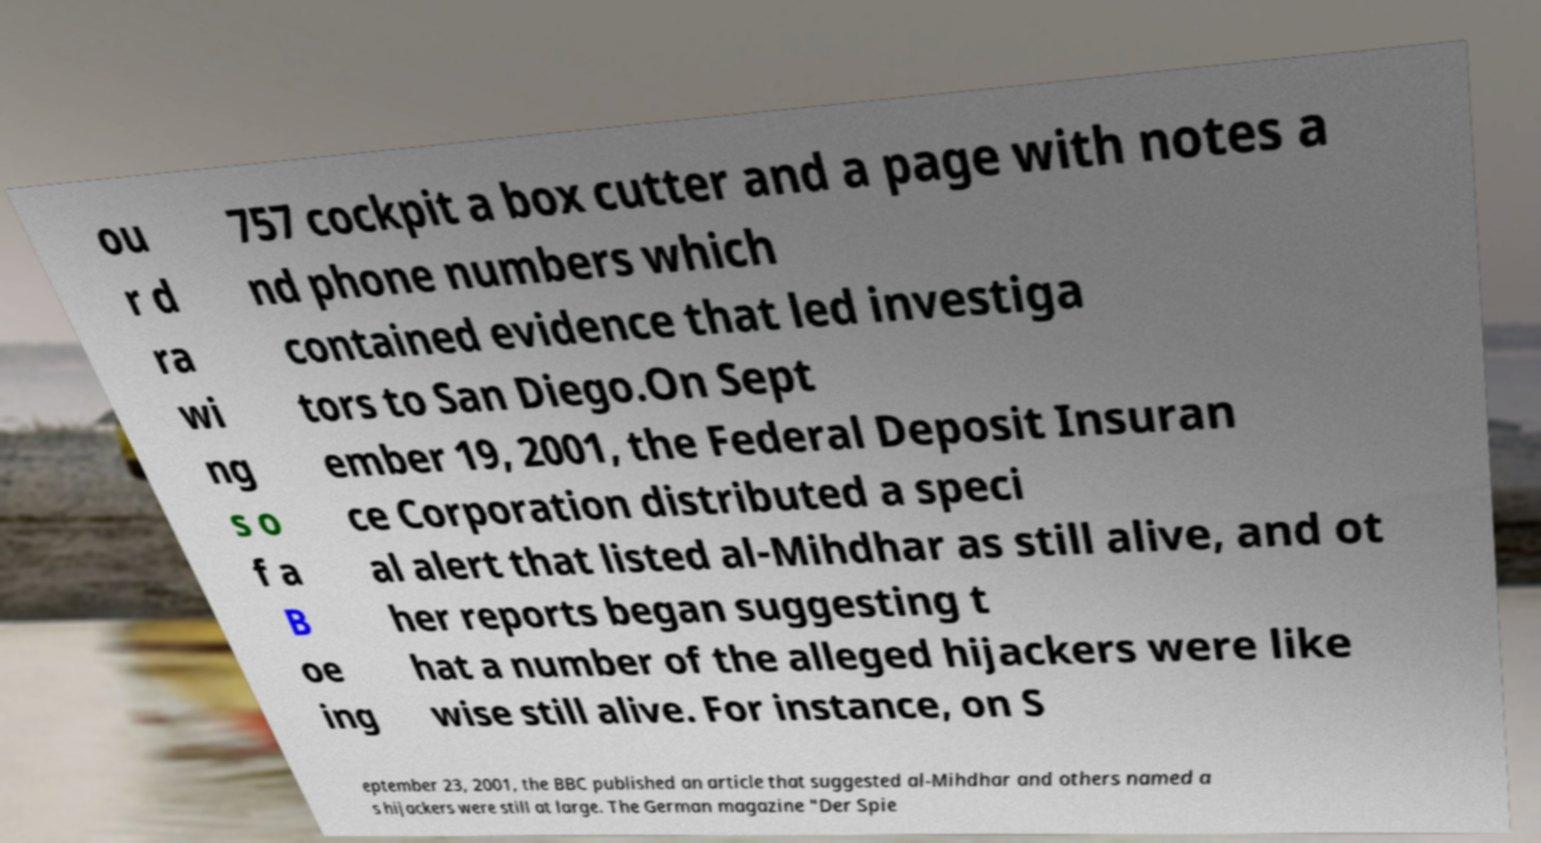Can you read and provide the text displayed in the image?This photo seems to have some interesting text. Can you extract and type it out for me? ou r d ra wi ng s o f a B oe ing 757 cockpit a box cutter and a page with notes a nd phone numbers which contained evidence that led investiga tors to San Diego.On Sept ember 19, 2001, the Federal Deposit Insuran ce Corporation distributed a speci al alert that listed al-Mihdhar as still alive, and ot her reports began suggesting t hat a number of the alleged hijackers were like wise still alive. For instance, on S eptember 23, 2001, the BBC published an article that suggested al-Mihdhar and others named a s hijackers were still at large. The German magazine "Der Spie 